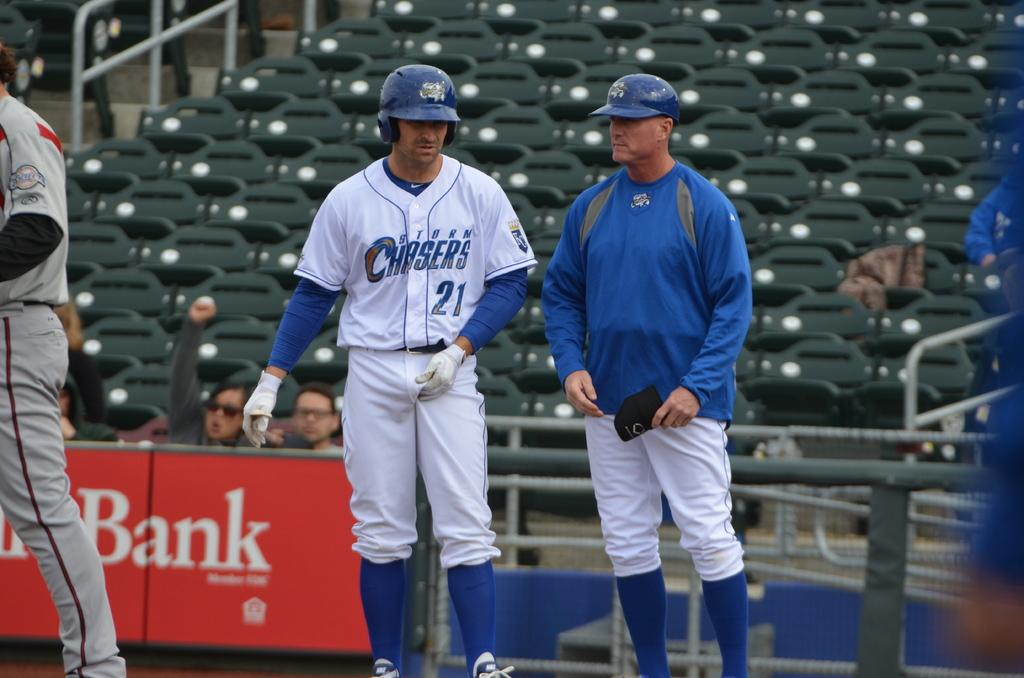<image>
Give a short and clear explanation of the subsequent image. a baseball player from the team storm chasers 